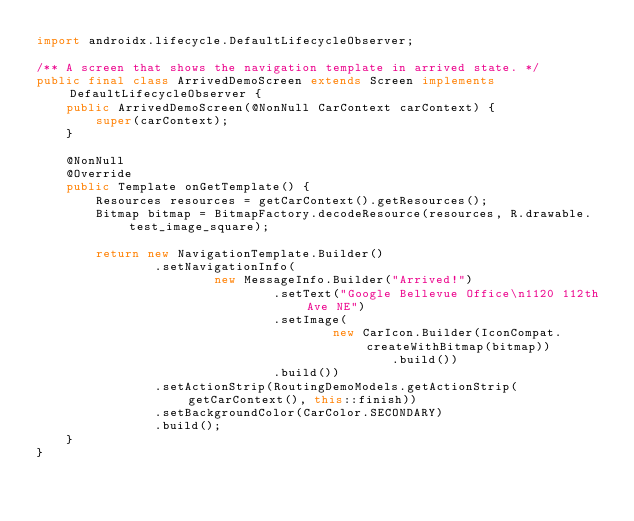Convert code to text. <code><loc_0><loc_0><loc_500><loc_500><_Java_>import androidx.lifecycle.DefaultLifecycleObserver;

/** A screen that shows the navigation template in arrived state. */
public final class ArrivedDemoScreen extends Screen implements DefaultLifecycleObserver {
    public ArrivedDemoScreen(@NonNull CarContext carContext) {
        super(carContext);
    }

    @NonNull
    @Override
    public Template onGetTemplate() {
        Resources resources = getCarContext().getResources();
        Bitmap bitmap = BitmapFactory.decodeResource(resources, R.drawable.test_image_square);

        return new NavigationTemplate.Builder()
                .setNavigationInfo(
                        new MessageInfo.Builder("Arrived!")
                                .setText("Google Bellevue Office\n1120 112th Ave NE")
                                .setImage(
                                        new CarIcon.Builder(IconCompat.createWithBitmap(bitmap))
                                                .build())
                                .build())
                .setActionStrip(RoutingDemoModels.getActionStrip(getCarContext(), this::finish))
                .setBackgroundColor(CarColor.SECONDARY)
                .build();
    }
}
</code> 